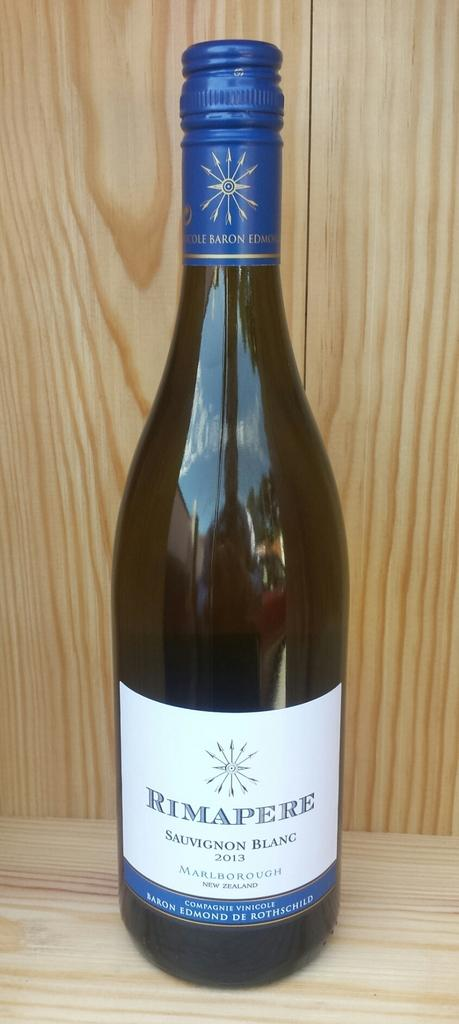What object is placed on the table in the image? There is a bottle on a table in the image. What type of material can be seen in the background of the image? There is a wooden wall in the background of the image. What type of tent can be seen in the image? There is no tent present in the image. How does the taste of the wooden wall compare to the bottle in the image? The wooden wall and the bottle in the image are not edible, so it is not possible to compare their tastes. 